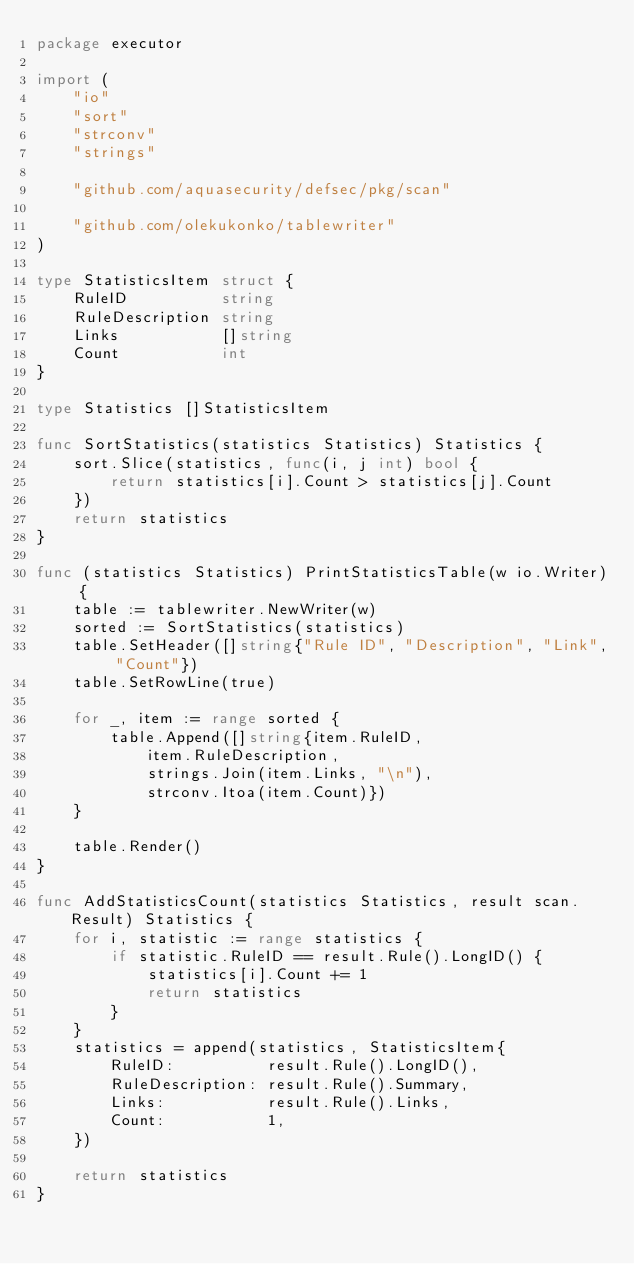<code> <loc_0><loc_0><loc_500><loc_500><_Go_>package executor

import (
	"io"
	"sort"
	"strconv"
	"strings"

	"github.com/aquasecurity/defsec/pkg/scan"

	"github.com/olekukonko/tablewriter"
)

type StatisticsItem struct {
	RuleID          string
	RuleDescription string
	Links           []string
	Count           int
}

type Statistics []StatisticsItem

func SortStatistics(statistics Statistics) Statistics {
	sort.Slice(statistics, func(i, j int) bool {
		return statistics[i].Count > statistics[j].Count
	})
	return statistics
}

func (statistics Statistics) PrintStatisticsTable(w io.Writer) {
	table := tablewriter.NewWriter(w)
	sorted := SortStatistics(statistics)
	table.SetHeader([]string{"Rule ID", "Description", "Link", "Count"})
	table.SetRowLine(true)

	for _, item := range sorted {
		table.Append([]string{item.RuleID,
			item.RuleDescription,
			strings.Join(item.Links, "\n"),
			strconv.Itoa(item.Count)})
	}

	table.Render()
}

func AddStatisticsCount(statistics Statistics, result scan.Result) Statistics {
	for i, statistic := range statistics {
		if statistic.RuleID == result.Rule().LongID() {
			statistics[i].Count += 1
			return statistics
		}
	}
	statistics = append(statistics, StatisticsItem{
		RuleID:          result.Rule().LongID(),
		RuleDescription: result.Rule().Summary,
		Links:           result.Rule().Links,
		Count:           1,
	})

	return statistics
}
</code> 